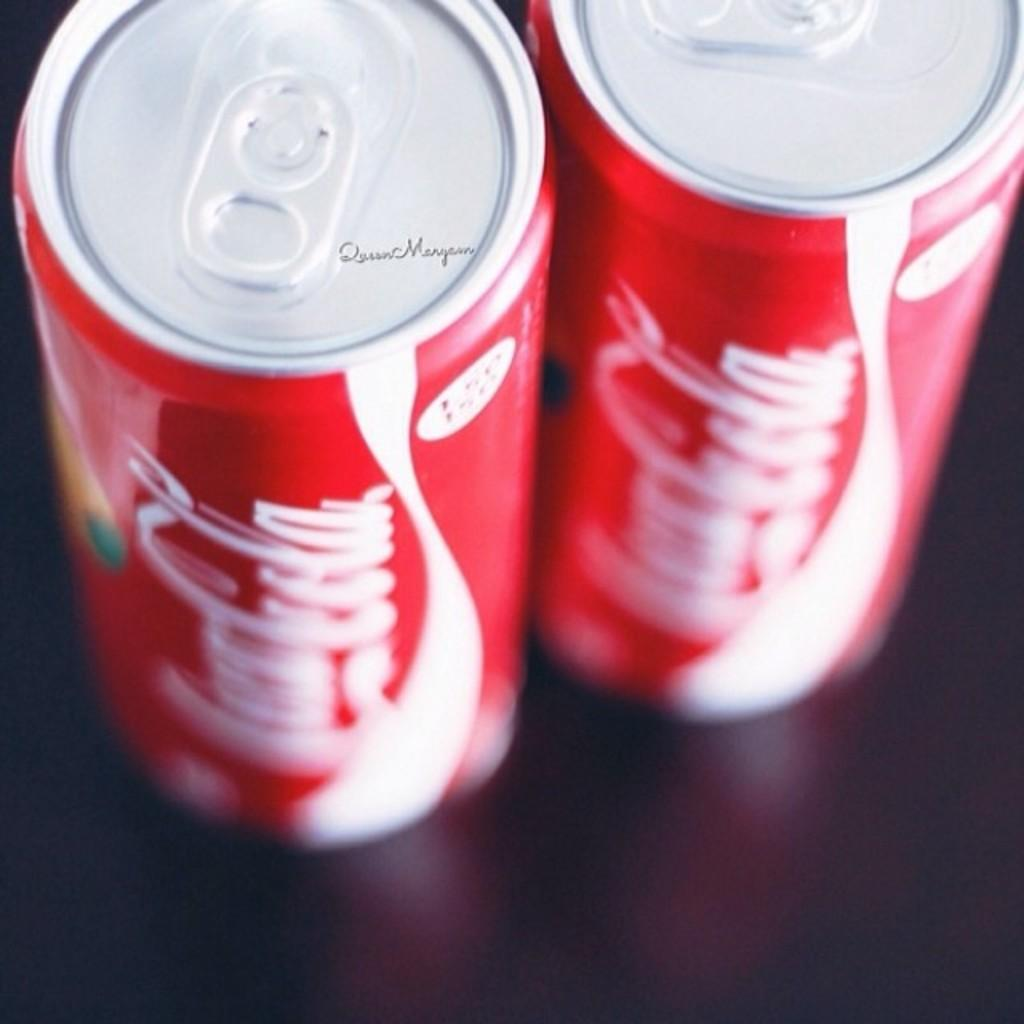<image>
Relay a brief, clear account of the picture shown. Two cans of Coca-Cola sit side by side. 